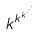<formula> <loc_0><loc_0><loc_500><loc_500>k ^ { k ^ { k ^ { \cdot ^ { \cdot ^ { \cdot } } } } }</formula> 